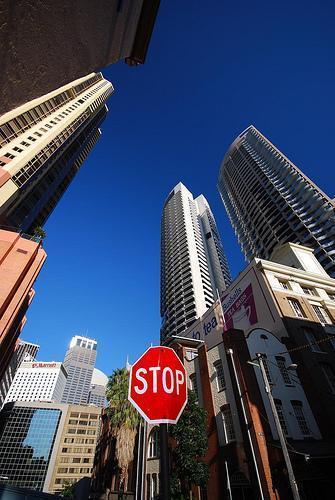How many people in the picture?
Give a very brief answer. 0. 